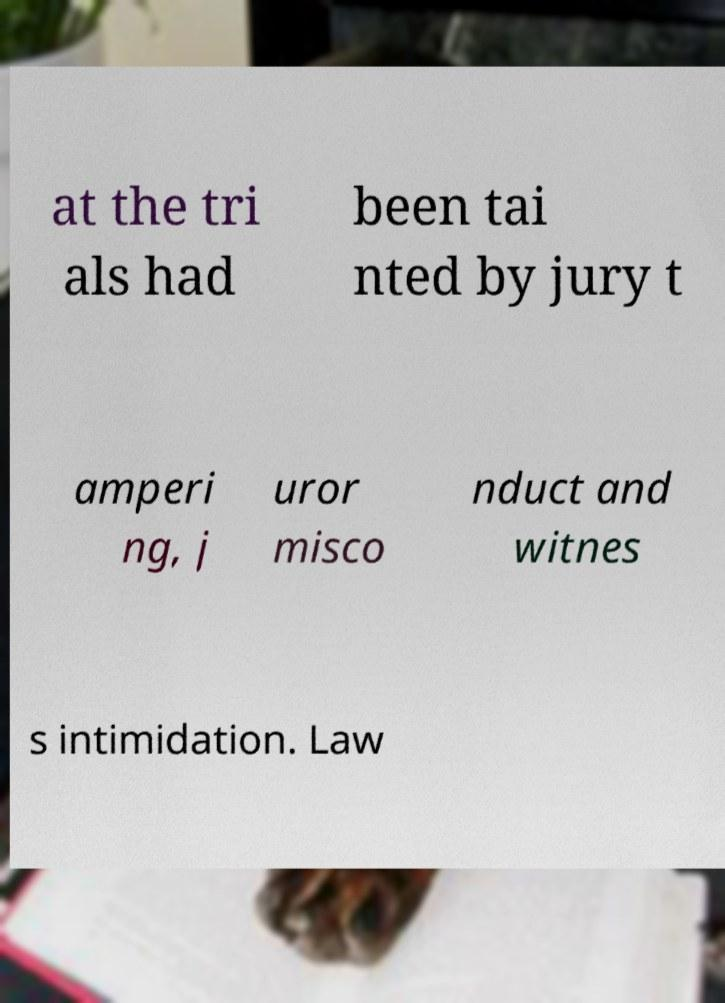Can you read and provide the text displayed in the image?This photo seems to have some interesting text. Can you extract and type it out for me? at the tri als had been tai nted by jury t amperi ng, j uror misco nduct and witnes s intimidation. Law 